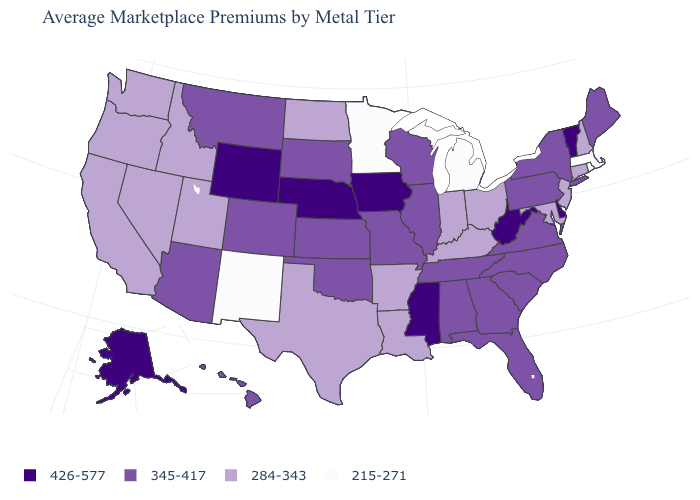What is the value of South Carolina?
Keep it brief. 345-417. Does the first symbol in the legend represent the smallest category?
Short answer required. No. Which states have the lowest value in the USA?
Write a very short answer. Massachusetts, Michigan, Minnesota, New Mexico, Rhode Island. What is the value of Connecticut?
Be succinct. 284-343. Name the states that have a value in the range 215-271?
Keep it brief. Massachusetts, Michigan, Minnesota, New Mexico, Rhode Island. Name the states that have a value in the range 426-577?
Quick response, please. Alaska, Delaware, Iowa, Mississippi, Nebraska, Vermont, West Virginia, Wyoming. Does Pennsylvania have a higher value than Virginia?
Concise answer only. No. Does Iowa have the highest value in the USA?
Quick response, please. Yes. Which states hav the highest value in the West?
Write a very short answer. Alaska, Wyoming. What is the highest value in the USA?
Short answer required. 426-577. Which states have the lowest value in the USA?
Keep it brief. Massachusetts, Michigan, Minnesota, New Mexico, Rhode Island. Does the map have missing data?
Concise answer only. No. What is the value of Mississippi?
Short answer required. 426-577. What is the highest value in the USA?
Short answer required. 426-577. What is the highest value in states that border Ohio?
Short answer required. 426-577. 